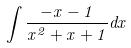Convert formula to latex. <formula><loc_0><loc_0><loc_500><loc_500>\int \frac { - x - 1 } { x ^ { 2 } + x + 1 } d x</formula> 